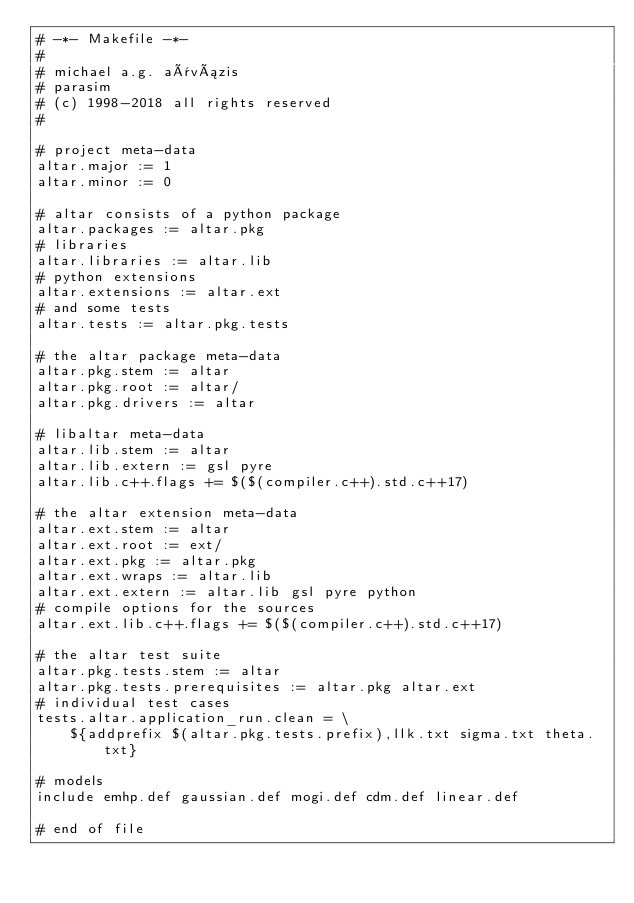<code> <loc_0><loc_0><loc_500><loc_500><_ObjectiveC_># -*- Makefile -*-
#
# michael a.g. aïvázis
# parasim
# (c) 1998-2018 all rights reserved
#

# project meta-data
altar.major := 1
altar.minor := 0

# altar consists of a python package
altar.packages := altar.pkg
# libraries
altar.libraries := altar.lib
# python extensions
altar.extensions := altar.ext
# and some tests
altar.tests := altar.pkg.tests

# the altar package meta-data
altar.pkg.stem := altar
altar.pkg.root := altar/
altar.pkg.drivers := altar

# libaltar meta-data
altar.lib.stem := altar
altar.lib.extern := gsl pyre
altar.lib.c++.flags += $($(compiler.c++).std.c++17)

# the altar extension meta-data
altar.ext.stem := altar
altar.ext.root := ext/
altar.ext.pkg := altar.pkg
altar.ext.wraps := altar.lib
altar.ext.extern := altar.lib gsl pyre python
# compile options for the sources
altar.ext.lib.c++.flags += $($(compiler.c++).std.c++17)

# the altar test suite
altar.pkg.tests.stem := altar
altar.pkg.tests.prerequisites := altar.pkg altar.ext
# individual test cases
tests.altar.application_run.clean = \
    ${addprefix $(altar.pkg.tests.prefix),llk.txt sigma.txt theta.txt}

# models
include emhp.def gaussian.def mogi.def cdm.def linear.def

# end of file
</code> 